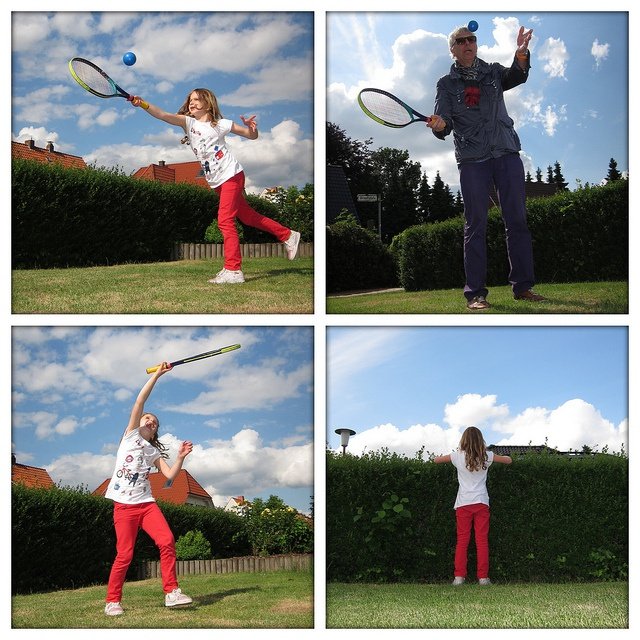Describe the objects in this image and their specific colors. I can see people in white, black, gray, and maroon tones, people in white, lightgray, maroon, brown, and black tones, people in white, red, and brown tones, people in white, brown, lightgray, maroon, and black tones, and tennis racket in white, lightgray, darkgray, and black tones in this image. 